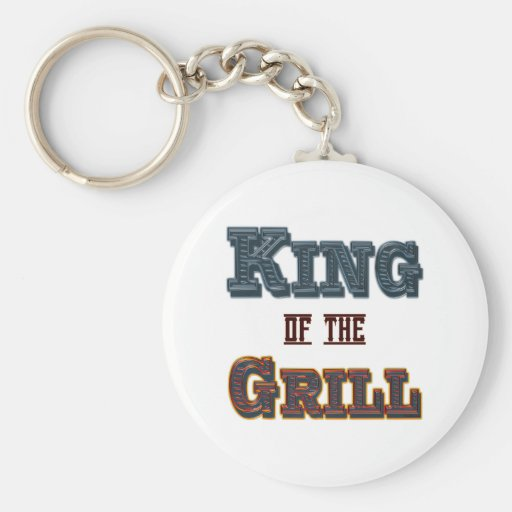How could this keychain be used in a marketing campaign for a new line of grills or barbecue accessories? This keychain could be an effective promotional item in a marketing campaign for a new line of grills or barbecue accessories. By branding it with the phrase 'KING OF THE GRILL', it could be used to evoke a sense of expertise and enthusiasm for grilling, appealing to the target audience's pride in their grilling abilities. It could be given away as a complimentary gift with a purchase, or as a limited-edition item at launch events, to increase customer engagement and enhance brand recall. Its appealing design and thematic relevance would make it a memorable part of the marketing effort, encouraging recipients to associate the brand with high-quality and enjoyment. 